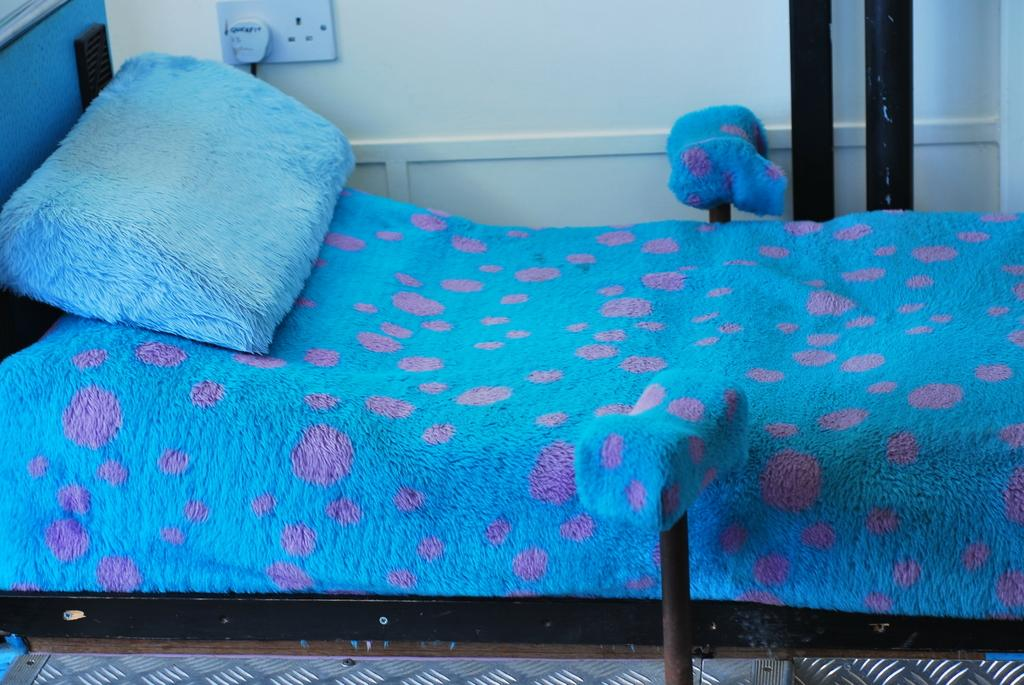What type of furniture is present in the image? There is a bed in the image. What is placed on the bed? There is a pillow in the image. Where is the straw located in the image? There is no straw present in the image. Can you see a lake in the background of the image? There is no lake visible in the image. 